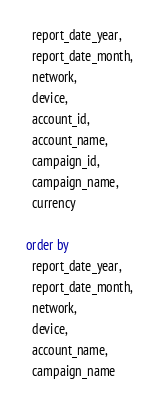Convert code to text. <code><loc_0><loc_0><loc_500><loc_500><_SQL_>  report_date_year,
  report_date_month,
  network,
  device,
  account_id,
  account_name,
  campaign_id,
  campaign_name,
  currency

order by
  report_date_year,
  report_date_month,
  network,
  device,
  account_name,
  campaign_name
</code> 